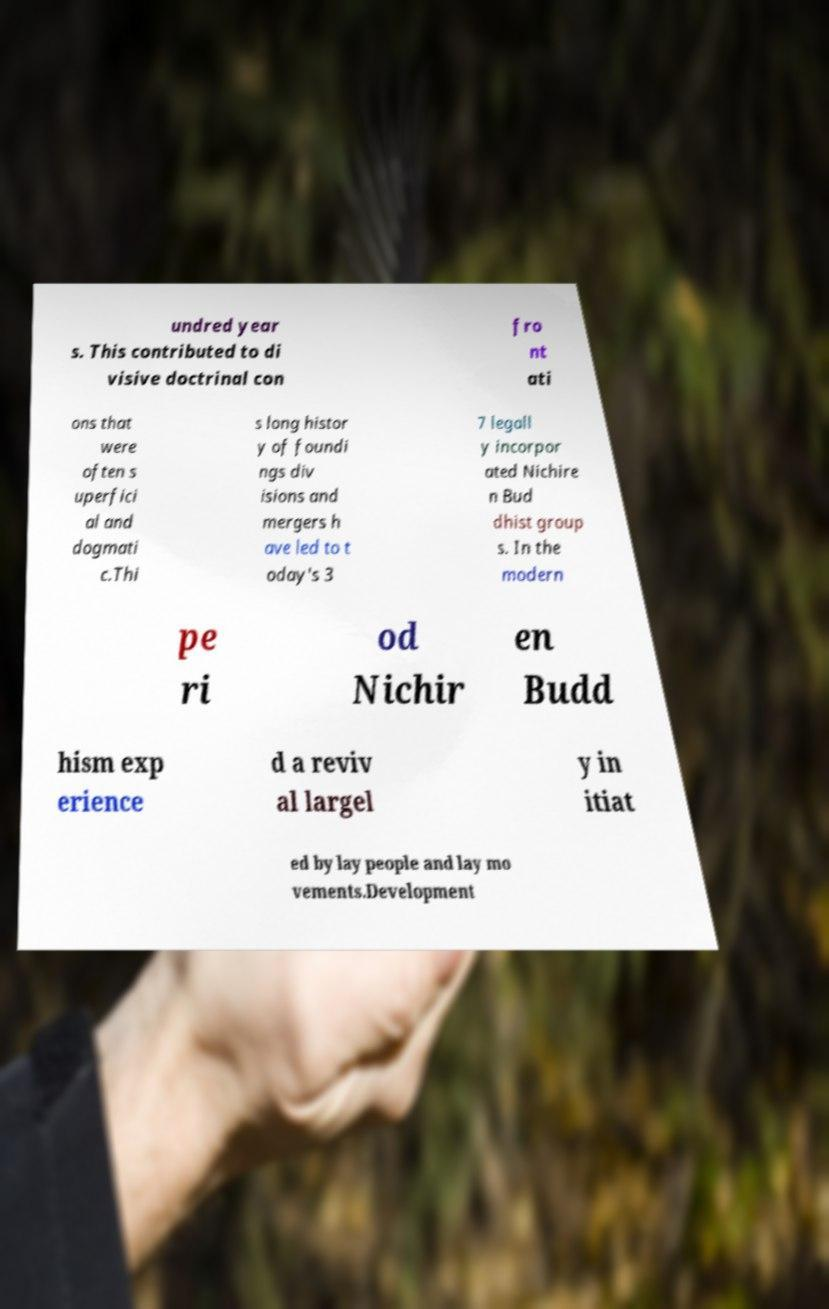Can you accurately transcribe the text from the provided image for me? undred year s. This contributed to di visive doctrinal con fro nt ati ons that were often s uperfici al and dogmati c.Thi s long histor y of foundi ngs div isions and mergers h ave led to t oday's 3 7 legall y incorpor ated Nichire n Bud dhist group s. In the modern pe ri od Nichir en Budd hism exp erience d a reviv al largel y in itiat ed by lay people and lay mo vements.Development 